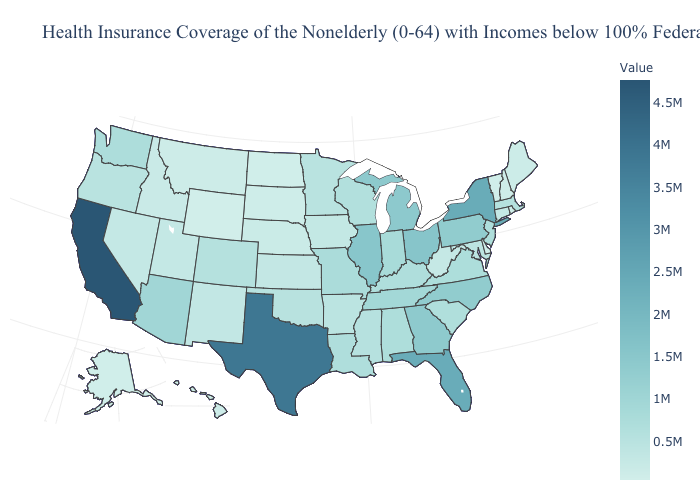Which states have the highest value in the USA?
Concise answer only. California. Which states have the highest value in the USA?
Answer briefly. California. 